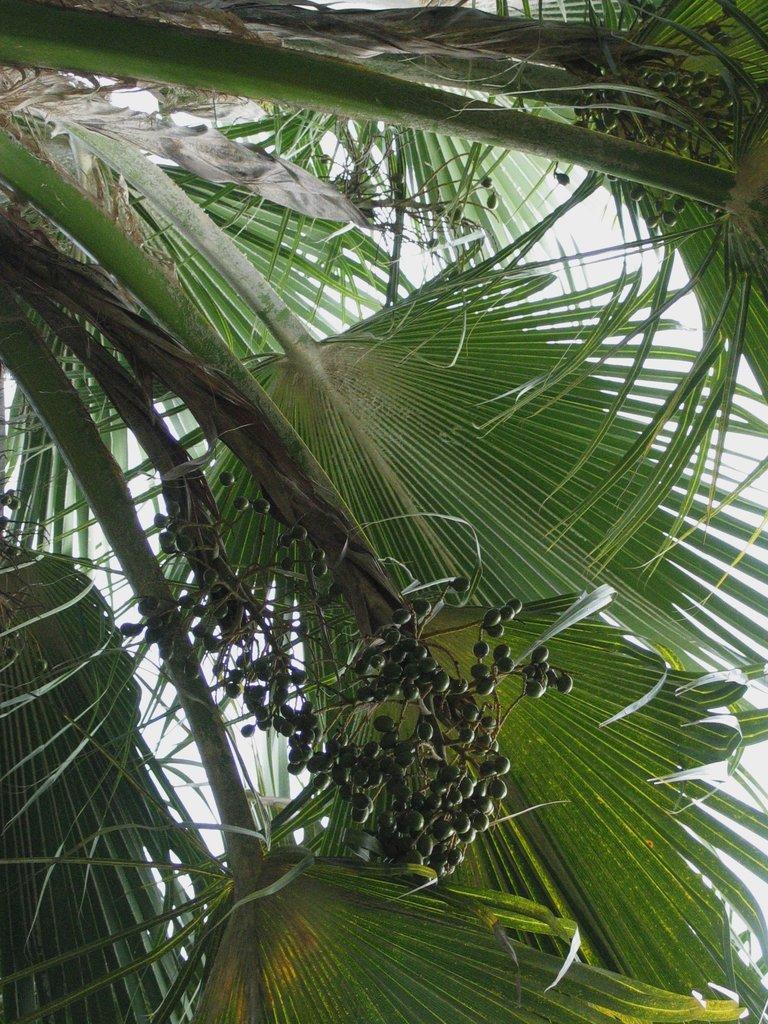How would you summarize this image in a sentence or two? In the picture we can see a tree with huge leaves and some small fruits to it. 